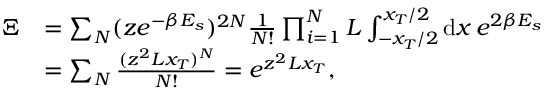Convert formula to latex. <formula><loc_0><loc_0><loc_500><loc_500>\begin{array} { r l } { \Xi } & { = \sum _ { N } ( z e ^ { - \beta E _ { s } } ) ^ { 2 N } \frac { 1 } { N ! } \prod _ { i = 1 } ^ { N } L \int _ { - x _ { T } / 2 } ^ { x _ { T } / 2 } d x \, e ^ { 2 \beta E _ { s } } } \\ & { = \sum _ { N } \frac { ( z ^ { 2 } L x _ { T } ) ^ { N } } { N ! } = e ^ { z ^ { 2 } L x _ { T } } , } \end{array}</formula> 